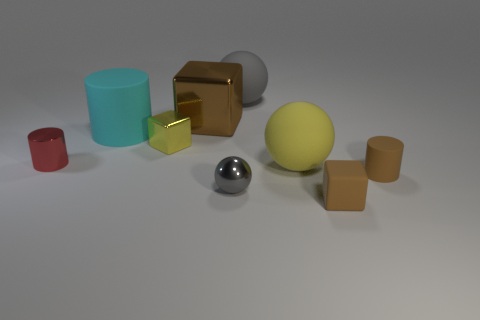Subtract all red spheres. How many brown cubes are left? 2 Subtract 1 spheres. How many spheres are left? 2 Subtract all balls. How many objects are left? 6 Add 1 big green spheres. How many big green spheres exist? 1 Subtract 0 gray cubes. How many objects are left? 9 Subtract all yellow rubber objects. Subtract all metal cubes. How many objects are left? 6 Add 2 matte objects. How many matte objects are left? 7 